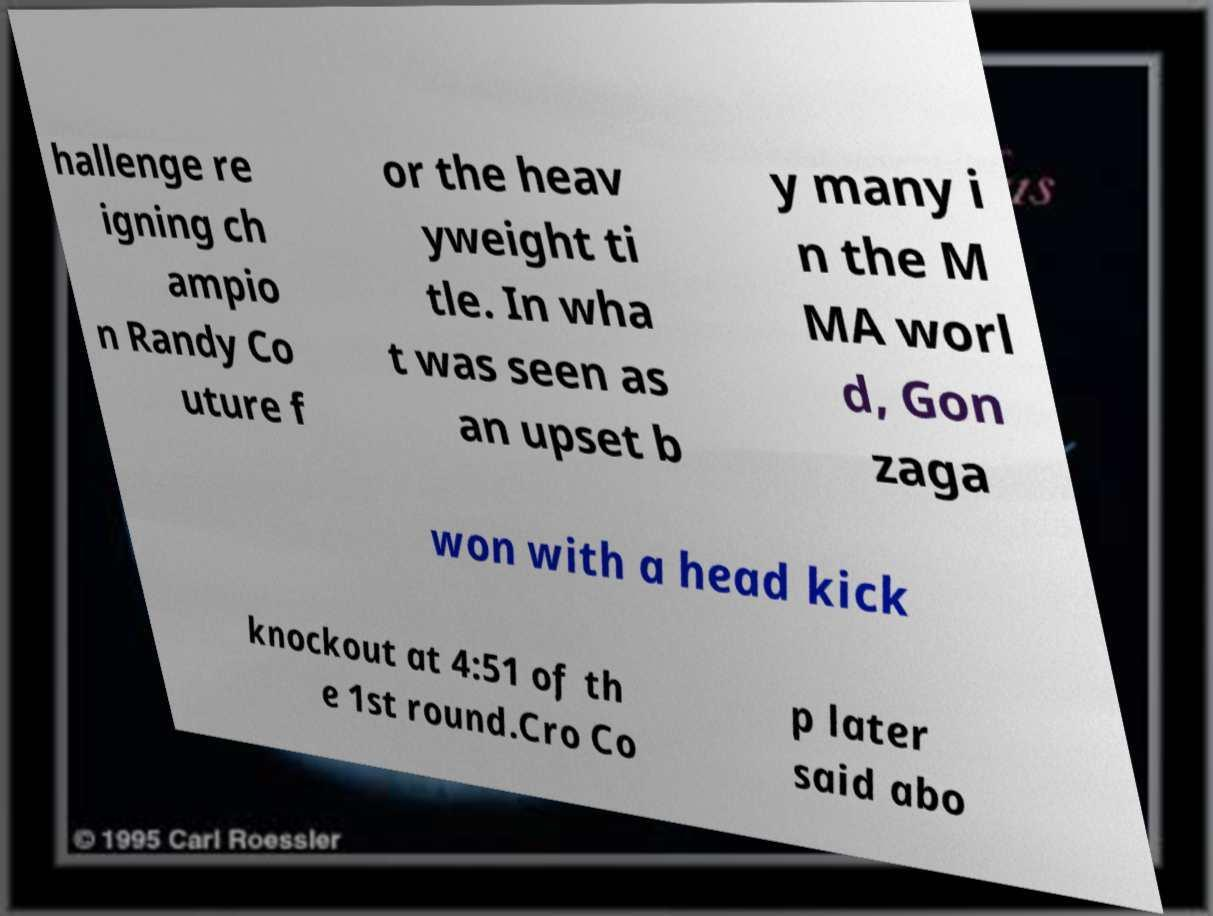Can you accurately transcribe the text from the provided image for me? hallenge re igning ch ampio n Randy Co uture f or the heav yweight ti tle. In wha t was seen as an upset b y many i n the M MA worl d, Gon zaga won with a head kick knockout at 4:51 of th e 1st round.Cro Co p later said abo 